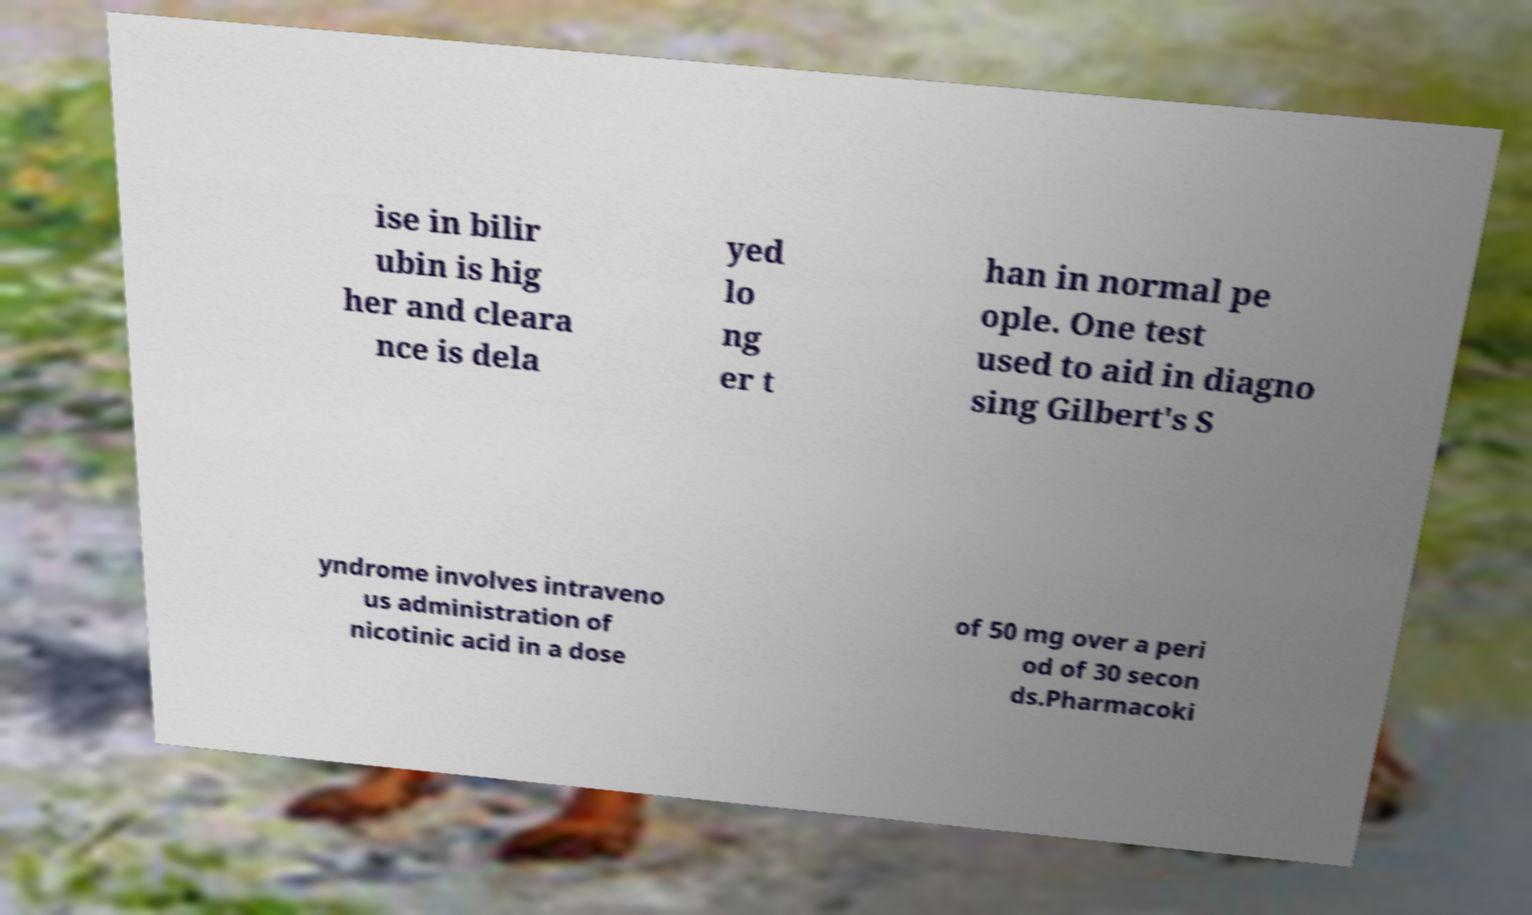Could you assist in decoding the text presented in this image and type it out clearly? ise in bilir ubin is hig her and cleara nce is dela yed lo ng er t han in normal pe ople. One test used to aid in diagno sing Gilbert's S yndrome involves intraveno us administration of nicotinic acid in a dose of 50 mg over a peri od of 30 secon ds.Pharmacoki 